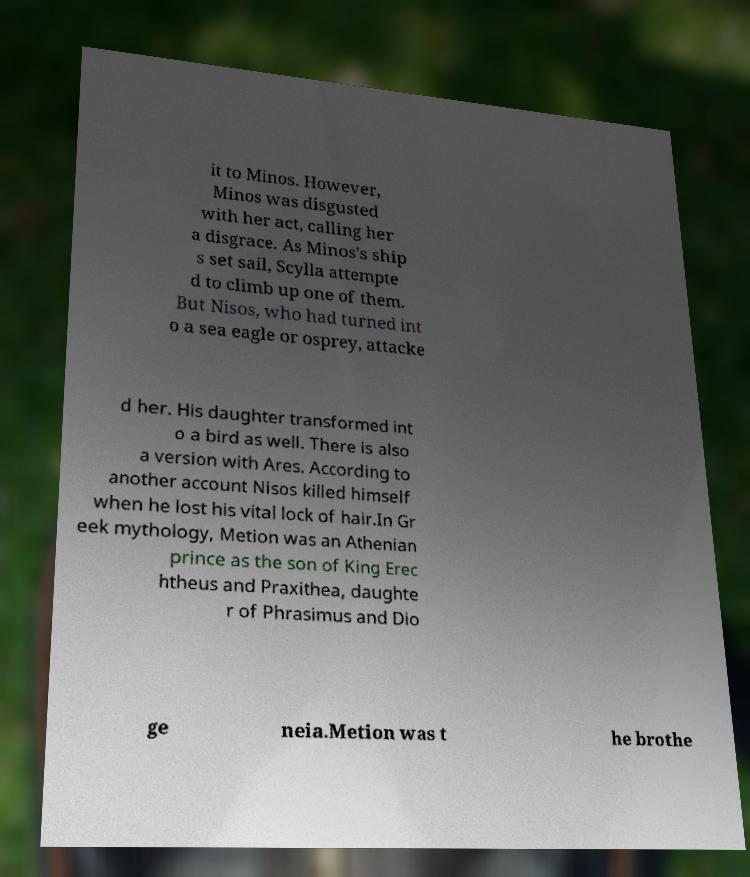Please identify and transcribe the text found in this image. it to Minos. However, Minos was disgusted with her act, calling her a disgrace. As Minos's ship s set sail, Scylla attempte d to climb up one of them. But Nisos, who had turned int o a sea eagle or osprey, attacke d her. His daughter transformed int o a bird as well. There is also a version with Ares. According to another account Nisos killed himself when he lost his vital lock of hair.In Gr eek mythology, Metion was an Athenian prince as the son of King Erec htheus and Praxithea, daughte r of Phrasimus and Dio ge neia.Metion was t he brothe 